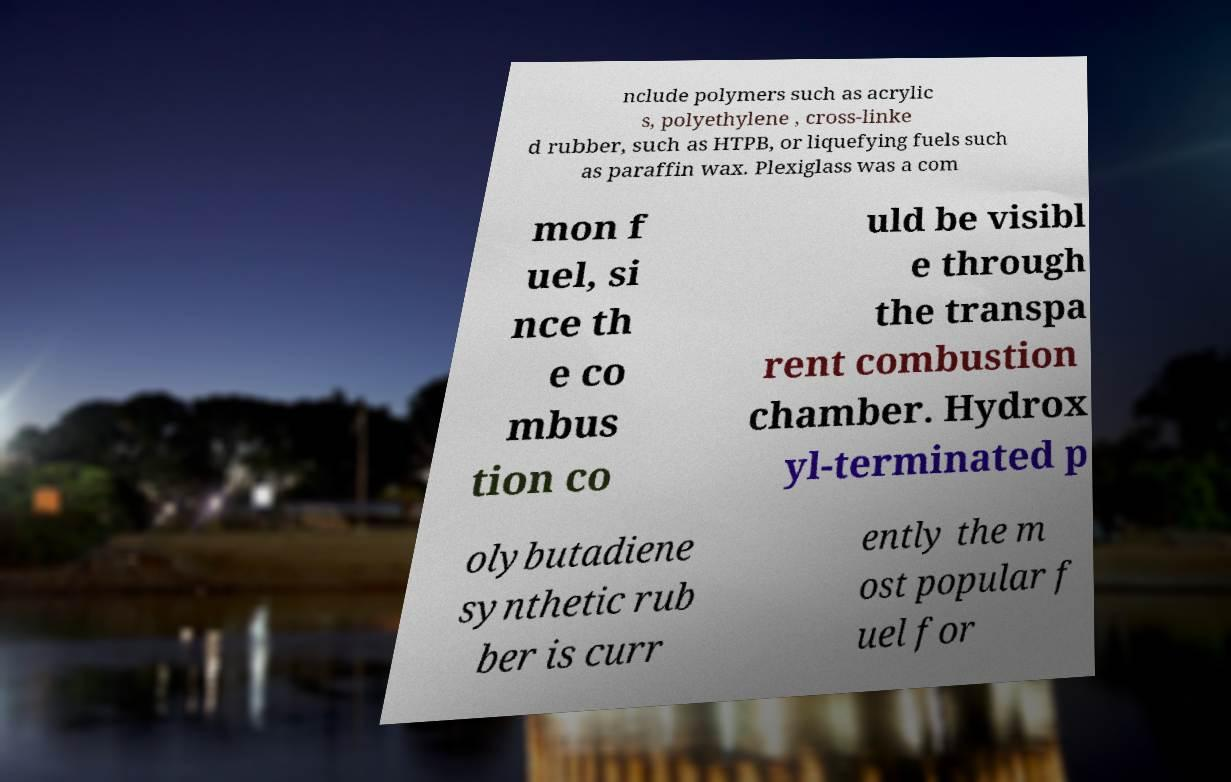There's text embedded in this image that I need extracted. Can you transcribe it verbatim? nclude polymers such as acrylic s, polyethylene , cross-linke d rubber, such as HTPB, or liquefying fuels such as paraffin wax. Plexiglass was a com mon f uel, si nce th e co mbus tion co uld be visibl e through the transpa rent combustion chamber. Hydrox yl-terminated p olybutadiene synthetic rub ber is curr ently the m ost popular f uel for 